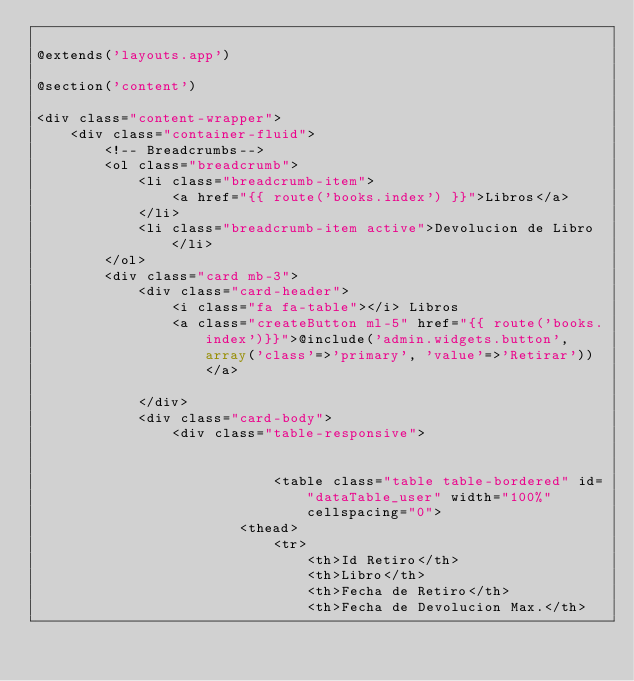Convert code to text. <code><loc_0><loc_0><loc_500><loc_500><_PHP_>
@extends('layouts.app')

@section('content')

<div class="content-wrapper">
    <div class="container-fluid">
        <!-- Breadcrumbs-->
        <ol class="breadcrumb">
            <li class="breadcrumb-item">
                <a href="{{ route('books.index') }}">Libros</a>
            </li>
            <li class="breadcrumb-item active">Devolucion de Libro</li>
        </ol>
        <div class="card mb-3">
            <div class="card-header">
                <i class="fa fa-table"></i> Libros
                <a class="createButton ml-5" href="{{ route('books.index')}}">@include('admin.widgets.button', array('class'=>'primary', 'value'=>'Retirar'))</a>
                
            </div>         
            <div class="card-body">
                <div class="table-responsive">
                    
                        
                            <table class="table table-bordered" id="dataTable_user" width="100%" cellspacing="0">                        
                        <thead>
                            <tr>
                                <th>Id Retiro</th>
                                <th>Libro</th>                                
                                <th>Fecha de Retiro</th>
                                <th>Fecha de Devolucion Max.</th></code> 